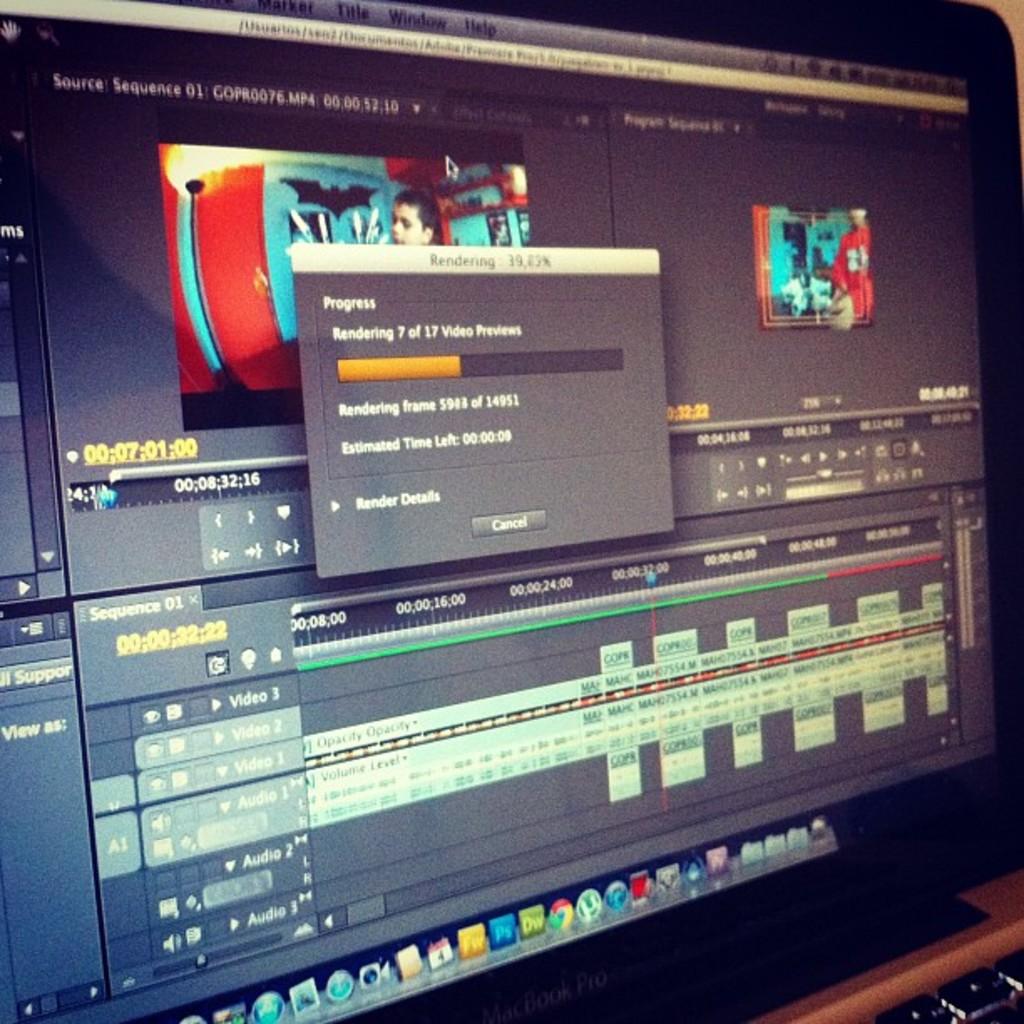Is the project in progress?
Keep it short and to the point. Yes. Does that say rendering above the progress bar?
Ensure brevity in your answer.  Yes. 